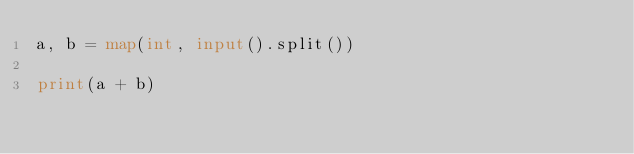<code> <loc_0><loc_0><loc_500><loc_500><_Python_>a, b = map(int, input().split())

print(a + b)</code> 